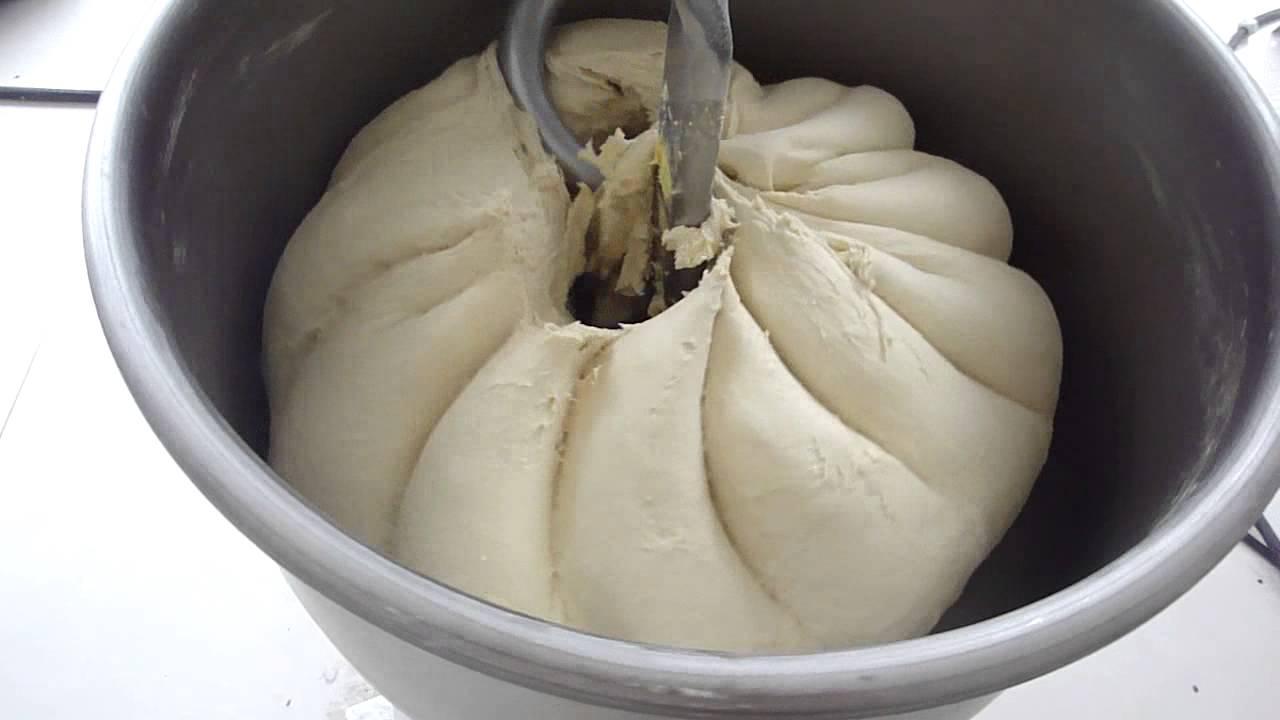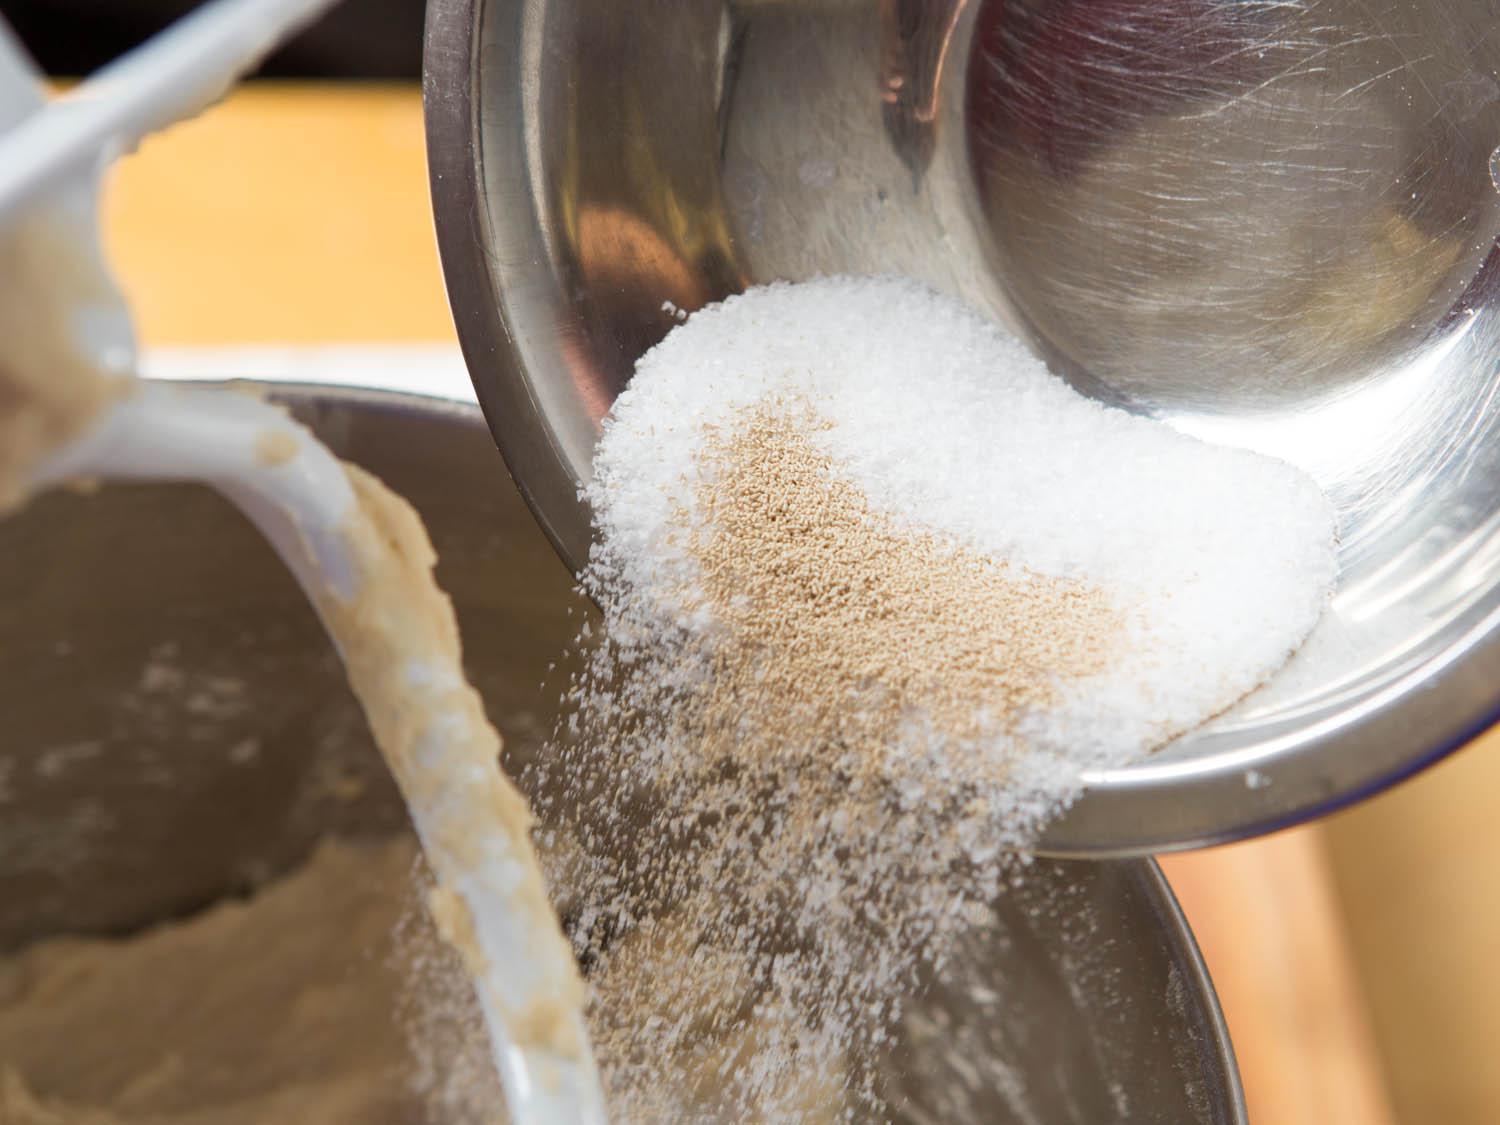The first image is the image on the left, the second image is the image on the right. For the images displayed, is the sentence "In one of the images, the dough is being stirred by a mixer." factually correct? Answer yes or no. Yes. The first image is the image on the left, the second image is the image on the right. Examine the images to the left and right. Is the description "Only one wooden spoon is visible." accurate? Answer yes or no. No. 